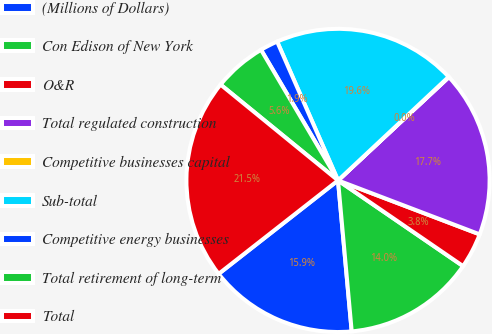<chart> <loc_0><loc_0><loc_500><loc_500><pie_chart><fcel>(Millions of Dollars)<fcel>Con Edison of New York<fcel>O&R<fcel>Total regulated construction<fcel>Competitive businesses capital<fcel>Sub-total<fcel>Competitive energy businesses<fcel>Total retirement of long-term<fcel>Total<nl><fcel>15.87%<fcel>14.0%<fcel>3.77%<fcel>17.73%<fcel>0.04%<fcel>19.6%<fcel>1.9%<fcel>5.63%<fcel>21.46%<nl></chart> 